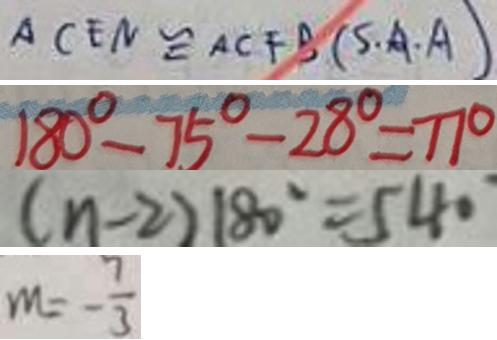<formula> <loc_0><loc_0><loc_500><loc_500>A C E N \cong A C F B ( S \cdot A \cdot A ) 
 1 8 0 ^ { \circ } - 7 5 ^ { \circ } - 2 8 ^ { \circ } = 7 7 ^ { \circ } 
 ( n - 2 ) 1 8 0 ^ { \circ } = 5 4 0 ^ { \circ } 
 m = - \frac { 7 } { 3 }</formula> 